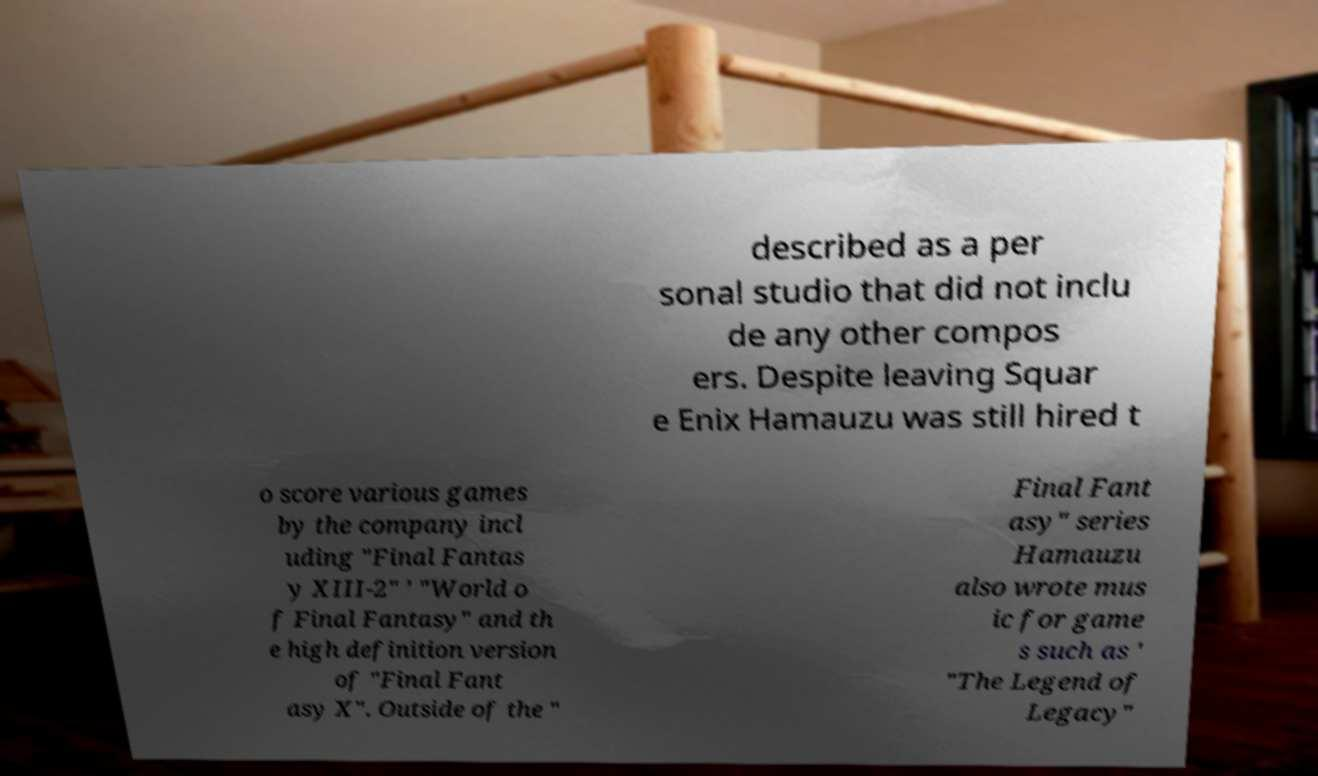Can you accurately transcribe the text from the provided image for me? described as a per sonal studio that did not inclu de any other compos ers. Despite leaving Squar e Enix Hamauzu was still hired t o score various games by the company incl uding "Final Fantas y XIII-2" ' "World o f Final Fantasy" and th e high definition version of "Final Fant asy X". Outside of the " Final Fant asy" series Hamauzu also wrote mus ic for game s such as ' "The Legend of Legacy" 